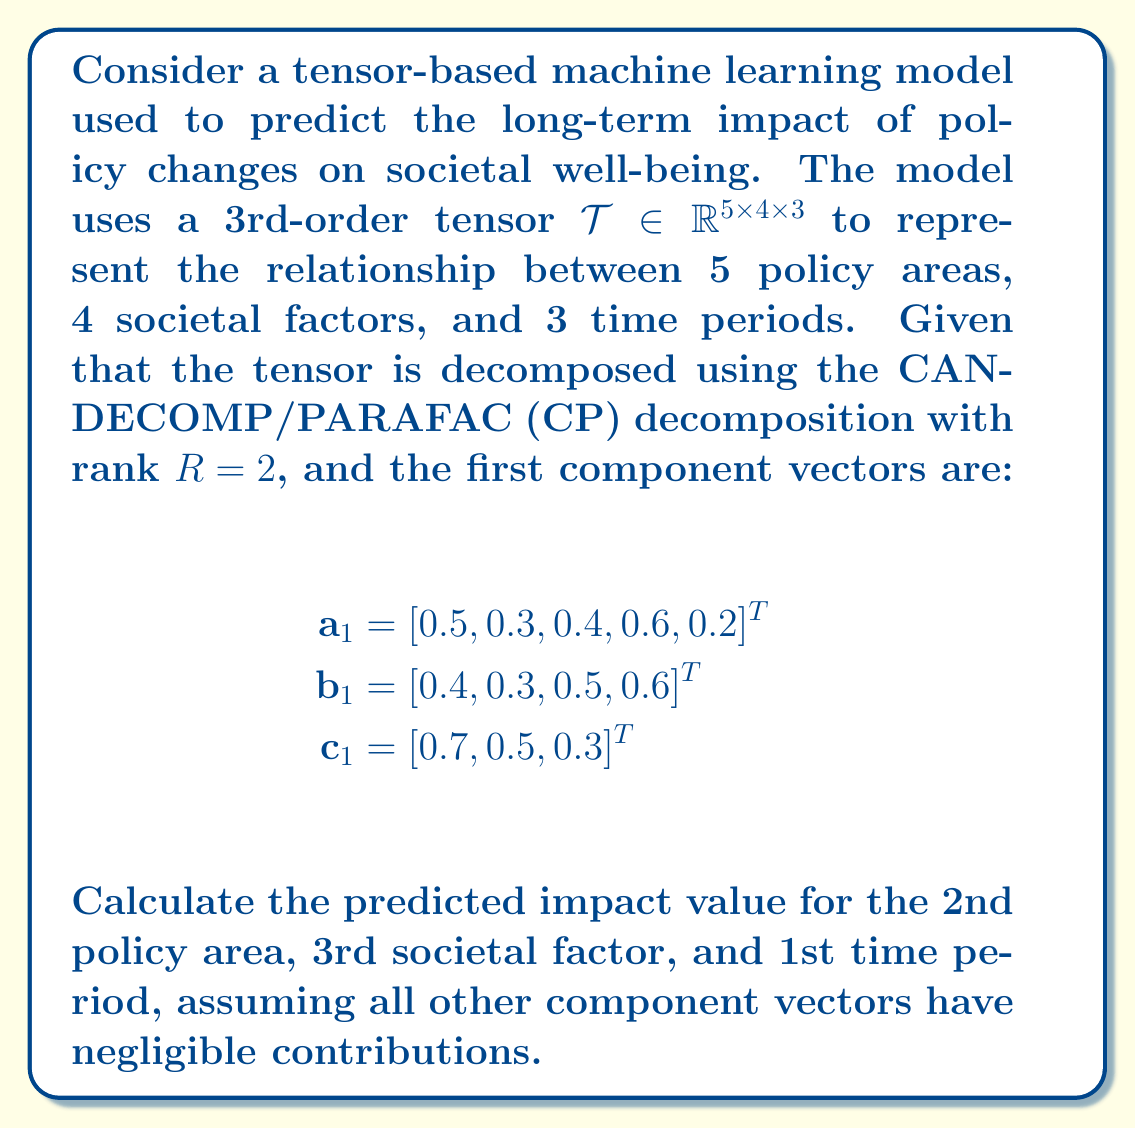Solve this math problem. To solve this problem, we need to understand the CP decomposition and how to use it to reconstruct tensor elements. Let's break it down step-by-step:

1) The CP decomposition approximates a tensor $\mathcal{T}$ as a sum of rank-one tensors:

   $$\mathcal{T} \approx \sum_{r=1}^R \mathbf{a}_r \circ \mathbf{b}_r \circ \mathbf{c}_r$$

   where $\circ$ denotes the outer product.

2) In this case, we're told that $R=2$, but the second component's contribution is negligible. So we only need to consider the first component:

   $$\mathcal{T} \approx \mathbf{a}_1 \circ \mathbf{b}_1 \circ \mathbf{c}_1$$

3) To find a specific element of the reconstructed tensor, we multiply the corresponding elements of each vector:

   $$t_{ijk} \approx a_{1i} \cdot b_{1j} \cdot c_{1k}$$

4) We're asked about the 2nd policy area, 3rd societal factor, and 1st time period. This corresponds to $i=2$, $j=3$, and $k=1$.

5) From the given vectors:
   - $a_{12} = 0.3$ (2nd element of $\mathbf{a}_1$)
   - $b_{13} = 0.5$ (3rd element of $\mathbf{b}_1$)
   - $c_{11} = 0.7$ (1st element of $\mathbf{c}_1$)

6) Multiplying these values:

   $$t_{231} \approx 0.3 \cdot 0.5 \cdot 0.7 = 0.105$$

Therefore, the predicted impact value for the specified combination is approximately 0.105.
Answer: 0.105 